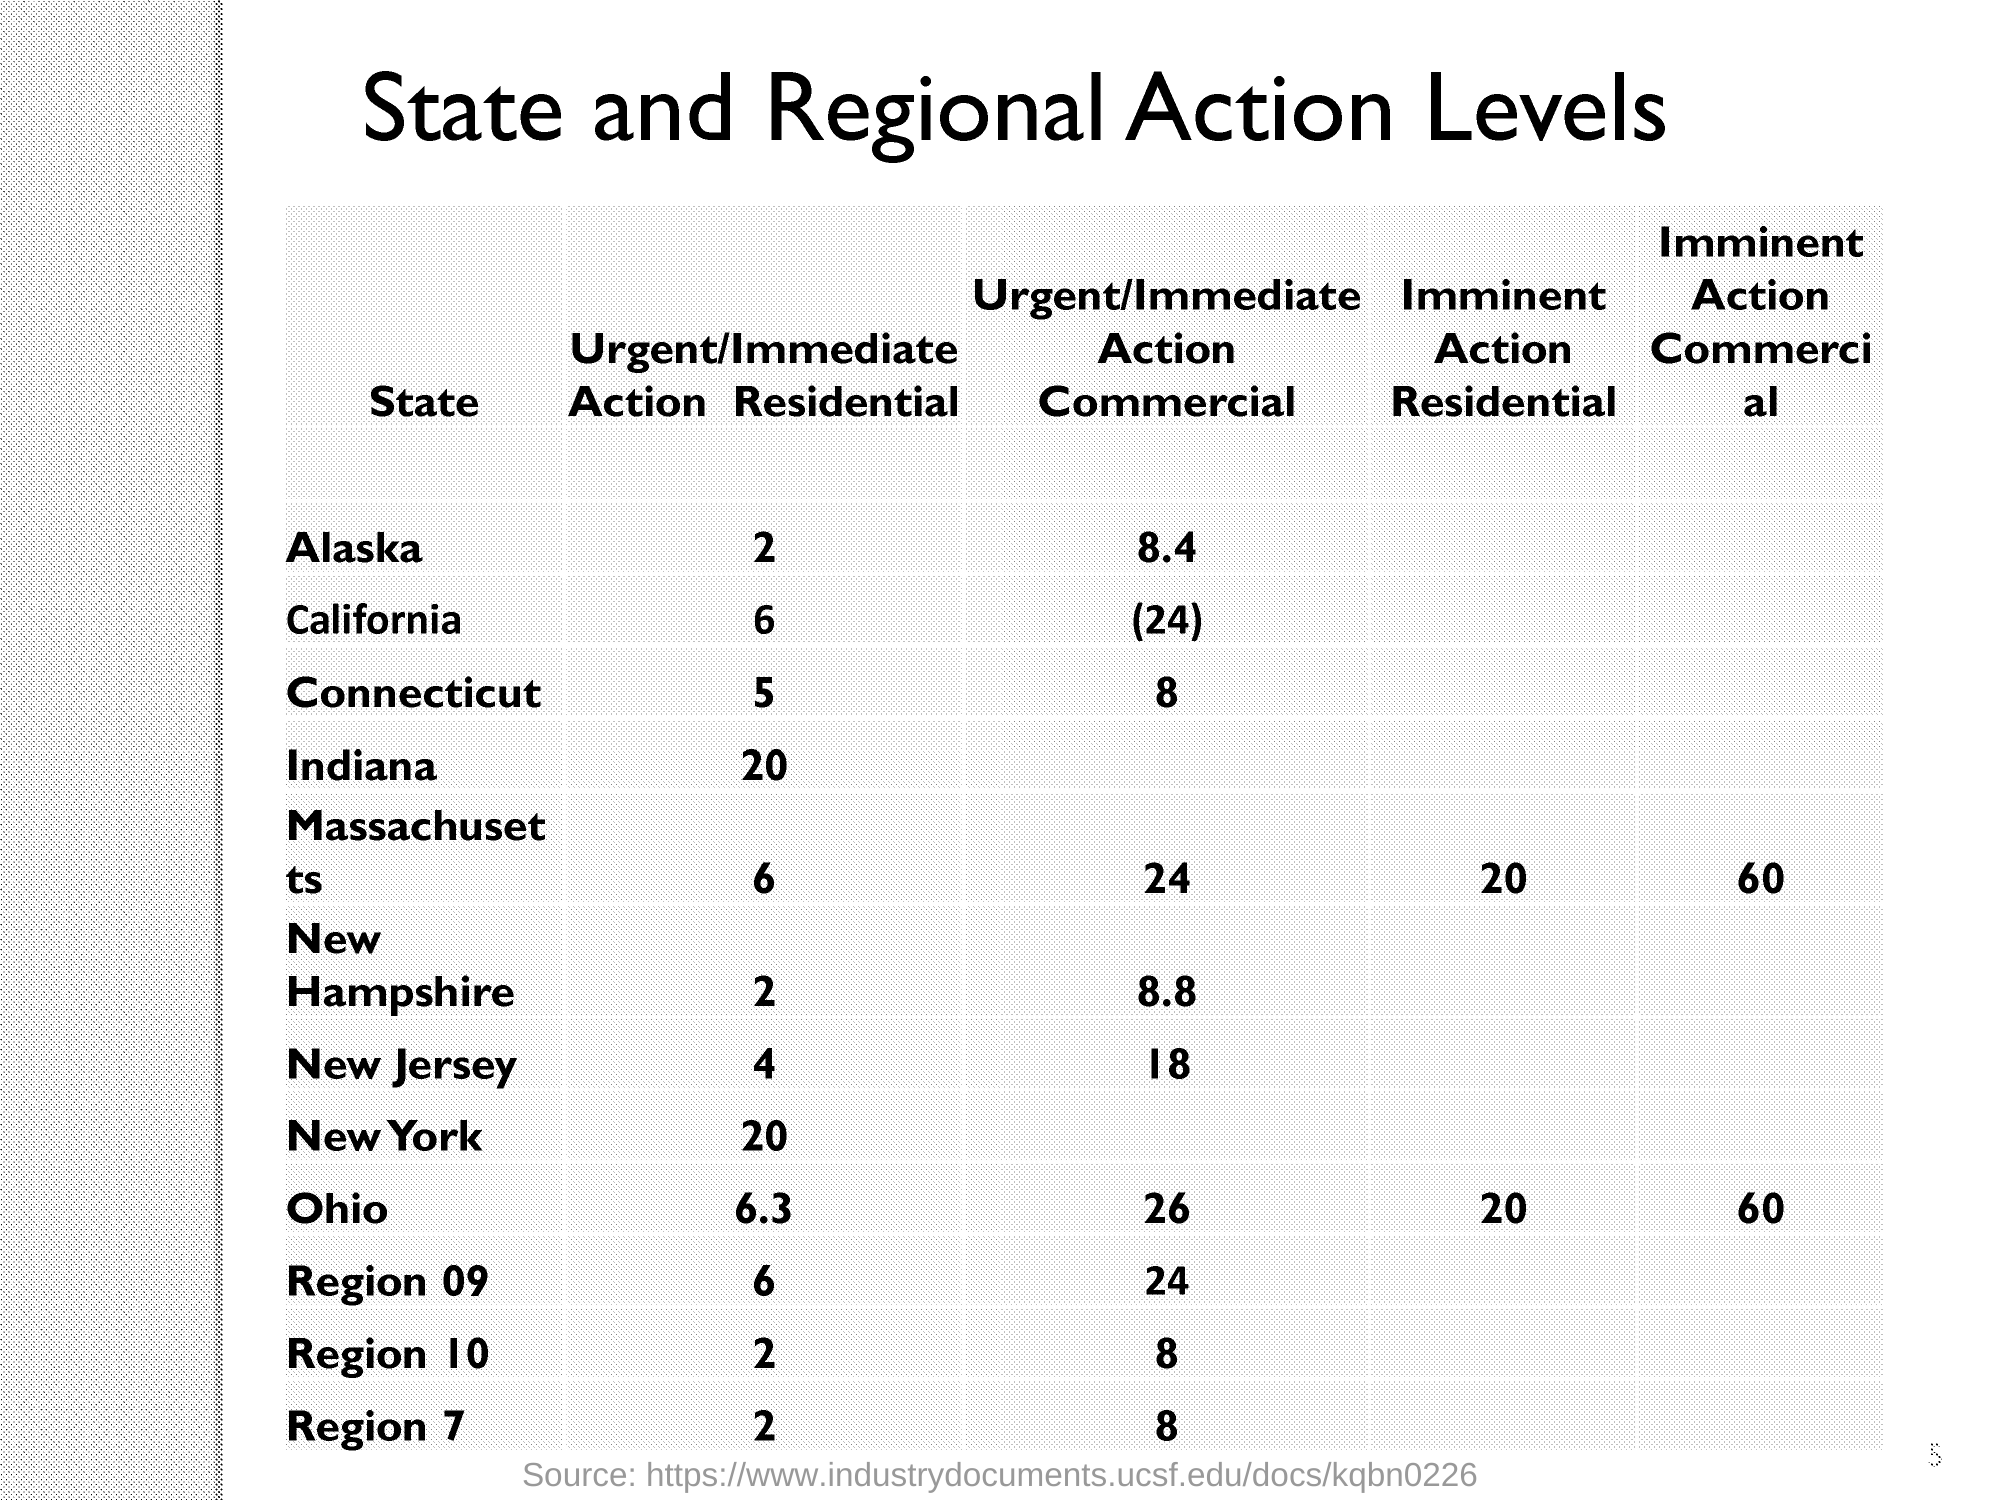Draw attention to some important aspects in this diagram. The Imminent Action Residential of Massachusetts (IARM) is a program that was established in 2020 to address the state's housing crisis. The Imminent Action Commercial of Ohio, also known as IACO 60, is a powerful tool that allows for the rapid deployment of troops and resources in response to a crisis or emergency. What is the Urgent/Immediate Action Commercial of Connecticut? 8.." is a question seeking information about a specific commercial, likely referring to an advertisement or marketing campaign. 